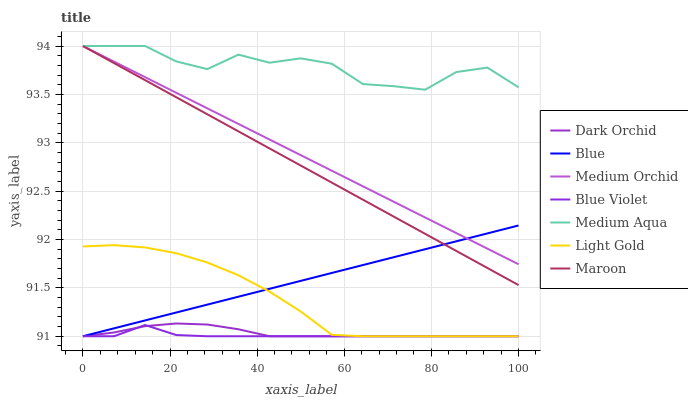Does Blue Violet have the minimum area under the curve?
Answer yes or no. Yes. Does Medium Aqua have the maximum area under the curve?
Answer yes or no. Yes. Does Medium Orchid have the minimum area under the curve?
Answer yes or no. No. Does Medium Orchid have the maximum area under the curve?
Answer yes or no. No. Is Medium Orchid the smoothest?
Answer yes or no. Yes. Is Medium Aqua the roughest?
Answer yes or no. Yes. Is Dark Orchid the smoothest?
Answer yes or no. No. Is Dark Orchid the roughest?
Answer yes or no. No. Does Medium Orchid have the lowest value?
Answer yes or no. No. Does Maroon have the highest value?
Answer yes or no. Yes. Does Dark Orchid have the highest value?
Answer yes or no. No. Is Dark Orchid less than Medium Orchid?
Answer yes or no. Yes. Is Medium Orchid greater than Light Gold?
Answer yes or no. Yes. Does Dark Orchid intersect Medium Orchid?
Answer yes or no. No. 